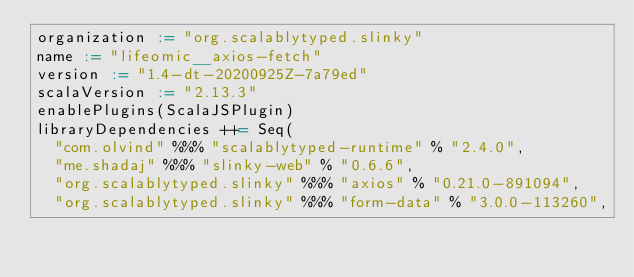Convert code to text. <code><loc_0><loc_0><loc_500><loc_500><_Scala_>organization := "org.scalablytyped.slinky"
name := "lifeomic__axios-fetch"
version := "1.4-dt-20200925Z-7a79ed"
scalaVersion := "2.13.3"
enablePlugins(ScalaJSPlugin)
libraryDependencies ++= Seq(
  "com.olvind" %%% "scalablytyped-runtime" % "2.4.0",
  "me.shadaj" %%% "slinky-web" % "0.6.6",
  "org.scalablytyped.slinky" %%% "axios" % "0.21.0-891094",
  "org.scalablytyped.slinky" %%% "form-data" % "3.0.0-113260",</code> 